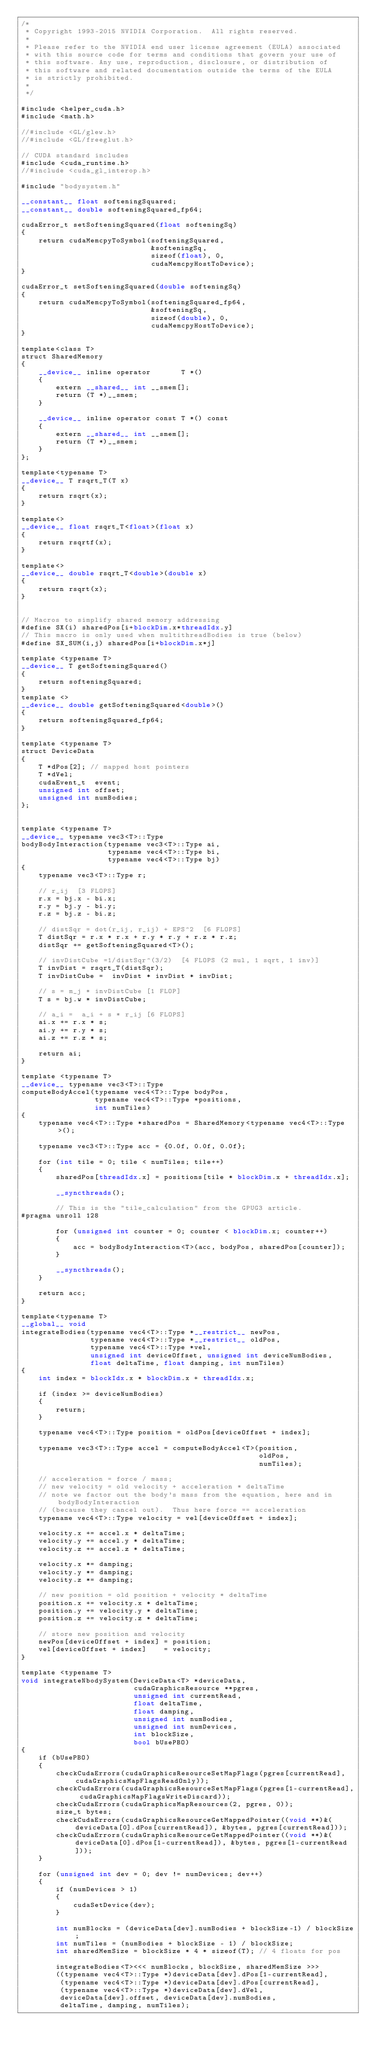<code> <loc_0><loc_0><loc_500><loc_500><_Cuda_>/*
 * Copyright 1993-2015 NVIDIA Corporation.  All rights reserved.
 *
 * Please refer to the NVIDIA end user license agreement (EULA) associated
 * with this source code for terms and conditions that govern your use of
 * this software. Any use, reproduction, disclosure, or distribution of
 * this software and related documentation outside the terms of the EULA
 * is strictly prohibited.
 *
 */

#include <helper_cuda.h>
#include <math.h>

//#include <GL/glew.h>
//#include <GL/freeglut.h>

// CUDA standard includes
#include <cuda_runtime.h>
//#include <cuda_gl_interop.h>

#include "bodysystem.h"

__constant__ float softeningSquared;
__constant__ double softeningSquared_fp64;

cudaError_t setSofteningSquared(float softeningSq)
{
    return cudaMemcpyToSymbol(softeningSquared,
                              &softeningSq,
                              sizeof(float), 0,
                              cudaMemcpyHostToDevice);
}

cudaError_t setSofteningSquared(double softeningSq)
{
    return cudaMemcpyToSymbol(softeningSquared_fp64,
                              &softeningSq,
                              sizeof(double), 0,
                              cudaMemcpyHostToDevice);
}

template<class T>
struct SharedMemory
{
    __device__ inline operator       T *()
    {
        extern __shared__ int __smem[];
        return (T *)__smem;
    }

    __device__ inline operator const T *() const
    {
        extern __shared__ int __smem[];
        return (T *)__smem;
    }
};

template<typename T>
__device__ T rsqrt_T(T x)
{
    return rsqrt(x);
}

template<>
__device__ float rsqrt_T<float>(float x)
{
    return rsqrtf(x);
}

template<>
__device__ double rsqrt_T<double>(double x)
{
    return rsqrt(x);
}


// Macros to simplify shared memory addressing
#define SX(i) sharedPos[i+blockDim.x*threadIdx.y]
// This macro is only used when multithreadBodies is true (below)
#define SX_SUM(i,j) sharedPos[i+blockDim.x*j]

template <typename T>
__device__ T getSofteningSquared()
{
    return softeningSquared;
}
template <>
__device__ double getSofteningSquared<double>()
{
    return softeningSquared_fp64;
}

template <typename T>
struct DeviceData
{
    T *dPos[2]; // mapped host pointers
    T *dVel;
    cudaEvent_t  event;
    unsigned int offset;
    unsigned int numBodies;
};


template <typename T>
__device__ typename vec3<T>::Type
bodyBodyInteraction(typename vec3<T>::Type ai,
                    typename vec4<T>::Type bi,
                    typename vec4<T>::Type bj)
{
    typename vec3<T>::Type r;

    // r_ij  [3 FLOPS]
    r.x = bj.x - bi.x;
    r.y = bj.y - bi.y;
    r.z = bj.z - bi.z;

    // distSqr = dot(r_ij, r_ij) + EPS^2  [6 FLOPS]
    T distSqr = r.x * r.x + r.y * r.y + r.z * r.z;
    distSqr += getSofteningSquared<T>();

    // invDistCube =1/distSqr^(3/2)  [4 FLOPS (2 mul, 1 sqrt, 1 inv)]
    T invDist = rsqrt_T(distSqr);
    T invDistCube =  invDist * invDist * invDist;

    // s = m_j * invDistCube [1 FLOP]
    T s = bj.w * invDistCube;

    // a_i =  a_i + s * r_ij [6 FLOPS]
    ai.x += r.x * s;
    ai.y += r.y * s;
    ai.z += r.z * s;

    return ai;
}

template <typename T>
__device__ typename vec3<T>::Type
computeBodyAccel(typename vec4<T>::Type bodyPos,
                 typename vec4<T>::Type *positions,
                 int numTiles)
{
    typename vec4<T>::Type *sharedPos = SharedMemory<typename vec4<T>::Type>();

    typename vec3<T>::Type acc = {0.0f, 0.0f, 0.0f};

    for (int tile = 0; tile < numTiles; tile++)
    {
        sharedPos[threadIdx.x] = positions[tile * blockDim.x + threadIdx.x];

        __syncthreads();

        // This is the "tile_calculation" from the GPUG3 article.
#pragma unroll 128

        for (unsigned int counter = 0; counter < blockDim.x; counter++)
        {
            acc = bodyBodyInteraction<T>(acc, bodyPos, sharedPos[counter]);
        }

        __syncthreads();
    }

    return acc;
}

template<typename T>
__global__ void
integrateBodies(typename vec4<T>::Type *__restrict__ newPos,
                typename vec4<T>::Type *__restrict__ oldPos,
                typename vec4<T>::Type *vel,
                unsigned int deviceOffset, unsigned int deviceNumBodies,
                float deltaTime, float damping, int numTiles)
{
    int index = blockIdx.x * blockDim.x + threadIdx.x;

    if (index >= deviceNumBodies)
    {
        return;
    }

    typename vec4<T>::Type position = oldPos[deviceOffset + index];

    typename vec3<T>::Type accel = computeBodyAccel<T>(position,
                                                       oldPos,
                                                       numTiles);

    // acceleration = force / mass;
    // new velocity = old velocity + acceleration * deltaTime
    // note we factor out the body's mass from the equation, here and in bodyBodyInteraction
    // (because they cancel out).  Thus here force == acceleration
    typename vec4<T>::Type velocity = vel[deviceOffset + index];

    velocity.x += accel.x * deltaTime;
    velocity.y += accel.y * deltaTime;
    velocity.z += accel.z * deltaTime;

    velocity.x *= damping;
    velocity.y *= damping;
    velocity.z *= damping;

    // new position = old position + velocity * deltaTime
    position.x += velocity.x * deltaTime;
    position.y += velocity.y * deltaTime;
    position.z += velocity.z * deltaTime;

    // store new position and velocity
    newPos[deviceOffset + index] = position;
    vel[deviceOffset + index]    = velocity;
}

template <typename T>
void integrateNbodySystem(DeviceData<T> *deviceData,
                          cudaGraphicsResource **pgres,
                          unsigned int currentRead,
                          float deltaTime,
                          float damping,
                          unsigned int numBodies,
                          unsigned int numDevices,
                          int blockSize,
                          bool bUsePBO)
{
    if (bUsePBO)
    {
        checkCudaErrors(cudaGraphicsResourceSetMapFlags(pgres[currentRead], cudaGraphicsMapFlagsReadOnly));
        checkCudaErrors(cudaGraphicsResourceSetMapFlags(pgres[1-currentRead], cudaGraphicsMapFlagsWriteDiscard));
        checkCudaErrors(cudaGraphicsMapResources(2, pgres, 0));
        size_t bytes;
        checkCudaErrors(cudaGraphicsResourceGetMappedPointer((void **)&(deviceData[0].dPos[currentRead]), &bytes, pgres[currentRead]));
        checkCudaErrors(cudaGraphicsResourceGetMappedPointer((void **)&(deviceData[0].dPos[1-currentRead]), &bytes, pgres[1-currentRead]));
    }

    for (unsigned int dev = 0; dev != numDevices; dev++)
    {
        if (numDevices > 1)
        {
            cudaSetDevice(dev);
        }

        int numBlocks = (deviceData[dev].numBodies + blockSize-1) / blockSize;
        int numTiles = (numBodies + blockSize - 1) / blockSize;
        int sharedMemSize = blockSize * 4 * sizeof(T); // 4 floats for pos

        integrateBodies<T><<< numBlocks, blockSize, sharedMemSize >>>
        ((typename vec4<T>::Type *)deviceData[dev].dPos[1-currentRead],
         (typename vec4<T>::Type *)deviceData[dev].dPos[currentRead],
         (typename vec4<T>::Type *)deviceData[dev].dVel,
         deviceData[dev].offset, deviceData[dev].numBodies,
         deltaTime, damping, numTiles);
</code> 